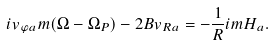Convert formula to latex. <formula><loc_0><loc_0><loc_500><loc_500>i v _ { \varphi a } m ( \Omega - \Omega _ { P } ) - 2 B v _ { R a } = - \frac { 1 } { R } i m H _ { a } .</formula> 